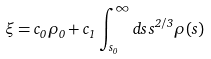<formula> <loc_0><loc_0><loc_500><loc_500>\xi = c _ { 0 } \rho _ { 0 } + c _ { 1 } \int _ { s _ { 0 } } ^ { \infty } d s \, s ^ { 2 / 3 } \rho ( s )</formula> 